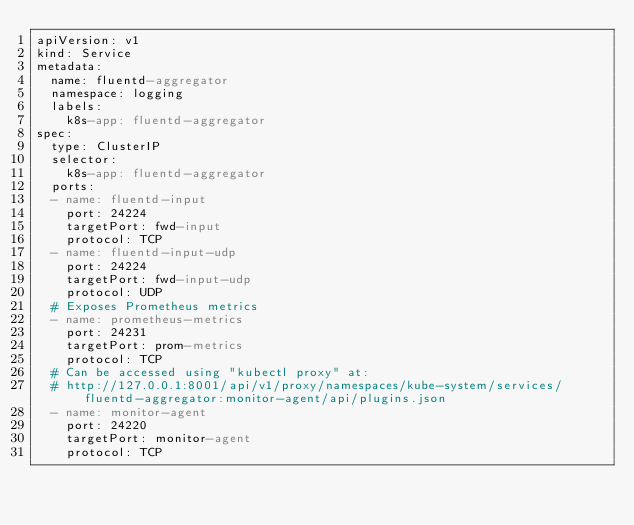Convert code to text. <code><loc_0><loc_0><loc_500><loc_500><_YAML_>apiVersion: v1
kind: Service
metadata:
  name: fluentd-aggregator
  namespace: logging
  labels:
    k8s-app: fluentd-aggregator
spec:
  type: ClusterIP
  selector:
    k8s-app: fluentd-aggregator
  ports:
  - name: fluentd-input
    port: 24224
    targetPort: fwd-input
    protocol: TCP
  - name: fluentd-input-udp
    port: 24224
    targetPort: fwd-input-udp
    protocol: UDP
  # Exposes Prometheus metrics
  - name: prometheus-metrics
    port: 24231
    targetPort: prom-metrics
    protocol: TCP
  # Can be accessed using "kubectl proxy" at:
  # http://127.0.0.1:8001/api/v1/proxy/namespaces/kube-system/services/fluentd-aggregator:monitor-agent/api/plugins.json
  - name: monitor-agent
    port: 24220
    targetPort: monitor-agent
    protocol: TCP
</code> 